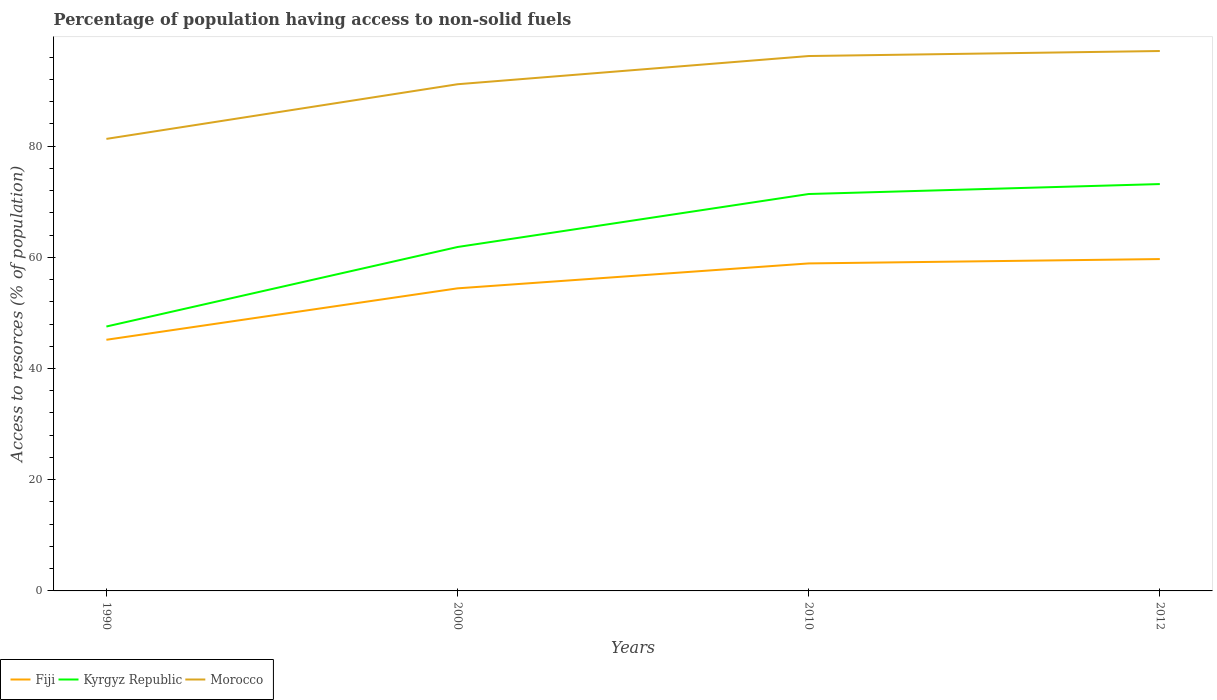How many different coloured lines are there?
Offer a terse response. 3. Is the number of lines equal to the number of legend labels?
Give a very brief answer. Yes. Across all years, what is the maximum percentage of population having access to non-solid fuels in Fiji?
Offer a very short reply. 45.17. What is the total percentage of population having access to non-solid fuels in Kyrgyz Republic in the graph?
Your answer should be compact. -14.3. What is the difference between the highest and the second highest percentage of population having access to non-solid fuels in Morocco?
Provide a succinct answer. 15.8. What is the difference between the highest and the lowest percentage of population having access to non-solid fuels in Morocco?
Ensure brevity in your answer.  2. How many lines are there?
Keep it short and to the point. 3. Where does the legend appear in the graph?
Provide a short and direct response. Bottom left. How are the legend labels stacked?
Offer a terse response. Horizontal. What is the title of the graph?
Provide a succinct answer. Percentage of population having access to non-solid fuels. What is the label or title of the X-axis?
Ensure brevity in your answer.  Years. What is the label or title of the Y-axis?
Provide a short and direct response. Access to resorces (% of population). What is the Access to resorces (% of population) of Fiji in 1990?
Make the answer very short. 45.17. What is the Access to resorces (% of population) of Kyrgyz Republic in 1990?
Your response must be concise. 47.55. What is the Access to resorces (% of population) in Morocco in 1990?
Give a very brief answer. 81.3. What is the Access to resorces (% of population) in Fiji in 2000?
Provide a succinct answer. 54.42. What is the Access to resorces (% of population) in Kyrgyz Republic in 2000?
Provide a succinct answer. 61.85. What is the Access to resorces (% of population) in Morocco in 2000?
Offer a terse response. 91.13. What is the Access to resorces (% of population) of Fiji in 2010?
Provide a short and direct response. 58.9. What is the Access to resorces (% of population) of Kyrgyz Republic in 2010?
Offer a very short reply. 71.38. What is the Access to resorces (% of population) in Morocco in 2010?
Your answer should be very brief. 96.2. What is the Access to resorces (% of population) of Fiji in 2012?
Make the answer very short. 59.68. What is the Access to resorces (% of population) in Kyrgyz Republic in 2012?
Provide a short and direct response. 73.18. What is the Access to resorces (% of population) of Morocco in 2012?
Make the answer very short. 97.1. Across all years, what is the maximum Access to resorces (% of population) in Fiji?
Make the answer very short. 59.68. Across all years, what is the maximum Access to resorces (% of population) in Kyrgyz Republic?
Provide a short and direct response. 73.18. Across all years, what is the maximum Access to resorces (% of population) of Morocco?
Ensure brevity in your answer.  97.1. Across all years, what is the minimum Access to resorces (% of population) in Fiji?
Ensure brevity in your answer.  45.17. Across all years, what is the minimum Access to resorces (% of population) in Kyrgyz Republic?
Provide a short and direct response. 47.55. Across all years, what is the minimum Access to resorces (% of population) of Morocco?
Offer a very short reply. 81.3. What is the total Access to resorces (% of population) of Fiji in the graph?
Offer a terse response. 218.17. What is the total Access to resorces (% of population) in Kyrgyz Republic in the graph?
Keep it short and to the point. 253.97. What is the total Access to resorces (% of population) of Morocco in the graph?
Your answer should be very brief. 365.73. What is the difference between the Access to resorces (% of population) of Fiji in 1990 and that in 2000?
Give a very brief answer. -9.25. What is the difference between the Access to resorces (% of population) in Kyrgyz Republic in 1990 and that in 2000?
Keep it short and to the point. -14.3. What is the difference between the Access to resorces (% of population) in Morocco in 1990 and that in 2000?
Make the answer very short. -9.83. What is the difference between the Access to resorces (% of population) in Fiji in 1990 and that in 2010?
Keep it short and to the point. -13.73. What is the difference between the Access to resorces (% of population) of Kyrgyz Republic in 1990 and that in 2010?
Your answer should be compact. -23.83. What is the difference between the Access to resorces (% of population) of Morocco in 1990 and that in 2010?
Provide a short and direct response. -14.9. What is the difference between the Access to resorces (% of population) in Fiji in 1990 and that in 2012?
Offer a very short reply. -14.52. What is the difference between the Access to resorces (% of population) in Kyrgyz Republic in 1990 and that in 2012?
Provide a succinct answer. -25.62. What is the difference between the Access to resorces (% of population) of Morocco in 1990 and that in 2012?
Make the answer very short. -15.8. What is the difference between the Access to resorces (% of population) in Fiji in 2000 and that in 2010?
Give a very brief answer. -4.48. What is the difference between the Access to resorces (% of population) in Kyrgyz Republic in 2000 and that in 2010?
Your response must be concise. -9.53. What is the difference between the Access to resorces (% of population) in Morocco in 2000 and that in 2010?
Keep it short and to the point. -5.07. What is the difference between the Access to resorces (% of population) of Fiji in 2000 and that in 2012?
Make the answer very short. -5.26. What is the difference between the Access to resorces (% of population) in Kyrgyz Republic in 2000 and that in 2012?
Give a very brief answer. -11.32. What is the difference between the Access to resorces (% of population) of Morocco in 2000 and that in 2012?
Offer a terse response. -5.98. What is the difference between the Access to resorces (% of population) of Fiji in 2010 and that in 2012?
Offer a very short reply. -0.78. What is the difference between the Access to resorces (% of population) of Kyrgyz Republic in 2010 and that in 2012?
Provide a succinct answer. -1.79. What is the difference between the Access to resorces (% of population) of Morocco in 2010 and that in 2012?
Your answer should be very brief. -0.9. What is the difference between the Access to resorces (% of population) of Fiji in 1990 and the Access to resorces (% of population) of Kyrgyz Republic in 2000?
Provide a succinct answer. -16.69. What is the difference between the Access to resorces (% of population) of Fiji in 1990 and the Access to resorces (% of population) of Morocco in 2000?
Your response must be concise. -45.96. What is the difference between the Access to resorces (% of population) of Kyrgyz Republic in 1990 and the Access to resorces (% of population) of Morocco in 2000?
Offer a terse response. -43.57. What is the difference between the Access to resorces (% of population) of Fiji in 1990 and the Access to resorces (% of population) of Kyrgyz Republic in 2010?
Keep it short and to the point. -26.21. What is the difference between the Access to resorces (% of population) of Fiji in 1990 and the Access to resorces (% of population) of Morocco in 2010?
Provide a short and direct response. -51.03. What is the difference between the Access to resorces (% of population) of Kyrgyz Republic in 1990 and the Access to resorces (% of population) of Morocco in 2010?
Provide a succinct answer. -48.65. What is the difference between the Access to resorces (% of population) of Fiji in 1990 and the Access to resorces (% of population) of Kyrgyz Republic in 2012?
Make the answer very short. -28.01. What is the difference between the Access to resorces (% of population) of Fiji in 1990 and the Access to resorces (% of population) of Morocco in 2012?
Keep it short and to the point. -51.93. What is the difference between the Access to resorces (% of population) of Kyrgyz Republic in 1990 and the Access to resorces (% of population) of Morocco in 2012?
Make the answer very short. -49.55. What is the difference between the Access to resorces (% of population) in Fiji in 2000 and the Access to resorces (% of population) in Kyrgyz Republic in 2010?
Make the answer very short. -16.96. What is the difference between the Access to resorces (% of population) in Fiji in 2000 and the Access to resorces (% of population) in Morocco in 2010?
Your response must be concise. -41.78. What is the difference between the Access to resorces (% of population) in Kyrgyz Republic in 2000 and the Access to resorces (% of population) in Morocco in 2010?
Make the answer very short. -34.35. What is the difference between the Access to resorces (% of population) of Fiji in 2000 and the Access to resorces (% of population) of Kyrgyz Republic in 2012?
Offer a terse response. -18.76. What is the difference between the Access to resorces (% of population) of Fiji in 2000 and the Access to resorces (% of population) of Morocco in 2012?
Keep it short and to the point. -42.68. What is the difference between the Access to resorces (% of population) of Kyrgyz Republic in 2000 and the Access to resorces (% of population) of Morocco in 2012?
Your response must be concise. -35.25. What is the difference between the Access to resorces (% of population) of Fiji in 2010 and the Access to resorces (% of population) of Kyrgyz Republic in 2012?
Keep it short and to the point. -14.27. What is the difference between the Access to resorces (% of population) of Fiji in 2010 and the Access to resorces (% of population) of Morocco in 2012?
Provide a succinct answer. -38.2. What is the difference between the Access to resorces (% of population) in Kyrgyz Republic in 2010 and the Access to resorces (% of population) in Morocco in 2012?
Offer a terse response. -25.72. What is the average Access to resorces (% of population) in Fiji per year?
Provide a short and direct response. 54.54. What is the average Access to resorces (% of population) of Kyrgyz Republic per year?
Keep it short and to the point. 63.49. What is the average Access to resorces (% of population) in Morocco per year?
Your response must be concise. 91.43. In the year 1990, what is the difference between the Access to resorces (% of population) of Fiji and Access to resorces (% of population) of Kyrgyz Republic?
Provide a succinct answer. -2.38. In the year 1990, what is the difference between the Access to resorces (% of population) in Fiji and Access to resorces (% of population) in Morocco?
Ensure brevity in your answer.  -36.13. In the year 1990, what is the difference between the Access to resorces (% of population) in Kyrgyz Republic and Access to resorces (% of population) in Morocco?
Provide a short and direct response. -33.75. In the year 2000, what is the difference between the Access to resorces (% of population) of Fiji and Access to resorces (% of population) of Kyrgyz Republic?
Offer a terse response. -7.43. In the year 2000, what is the difference between the Access to resorces (% of population) in Fiji and Access to resorces (% of population) in Morocco?
Offer a very short reply. -36.71. In the year 2000, what is the difference between the Access to resorces (% of population) of Kyrgyz Republic and Access to resorces (% of population) of Morocco?
Offer a terse response. -29.27. In the year 2010, what is the difference between the Access to resorces (% of population) in Fiji and Access to resorces (% of population) in Kyrgyz Republic?
Make the answer very short. -12.48. In the year 2010, what is the difference between the Access to resorces (% of population) in Fiji and Access to resorces (% of population) in Morocco?
Provide a succinct answer. -37.3. In the year 2010, what is the difference between the Access to resorces (% of population) of Kyrgyz Republic and Access to resorces (% of population) of Morocco?
Your response must be concise. -24.82. In the year 2012, what is the difference between the Access to resorces (% of population) in Fiji and Access to resorces (% of population) in Kyrgyz Republic?
Your answer should be very brief. -13.49. In the year 2012, what is the difference between the Access to resorces (% of population) in Fiji and Access to resorces (% of population) in Morocco?
Keep it short and to the point. -37.42. In the year 2012, what is the difference between the Access to resorces (% of population) in Kyrgyz Republic and Access to resorces (% of population) in Morocco?
Make the answer very short. -23.93. What is the ratio of the Access to resorces (% of population) of Fiji in 1990 to that in 2000?
Your response must be concise. 0.83. What is the ratio of the Access to resorces (% of population) of Kyrgyz Republic in 1990 to that in 2000?
Offer a very short reply. 0.77. What is the ratio of the Access to resorces (% of population) of Morocco in 1990 to that in 2000?
Ensure brevity in your answer.  0.89. What is the ratio of the Access to resorces (% of population) in Fiji in 1990 to that in 2010?
Your answer should be compact. 0.77. What is the ratio of the Access to resorces (% of population) of Kyrgyz Republic in 1990 to that in 2010?
Your answer should be compact. 0.67. What is the ratio of the Access to resorces (% of population) of Morocco in 1990 to that in 2010?
Your answer should be compact. 0.85. What is the ratio of the Access to resorces (% of population) in Fiji in 1990 to that in 2012?
Your answer should be very brief. 0.76. What is the ratio of the Access to resorces (% of population) in Kyrgyz Republic in 1990 to that in 2012?
Your answer should be compact. 0.65. What is the ratio of the Access to resorces (% of population) of Morocco in 1990 to that in 2012?
Your response must be concise. 0.84. What is the ratio of the Access to resorces (% of population) of Fiji in 2000 to that in 2010?
Give a very brief answer. 0.92. What is the ratio of the Access to resorces (% of population) of Kyrgyz Republic in 2000 to that in 2010?
Make the answer very short. 0.87. What is the ratio of the Access to resorces (% of population) of Morocco in 2000 to that in 2010?
Provide a succinct answer. 0.95. What is the ratio of the Access to resorces (% of population) of Fiji in 2000 to that in 2012?
Provide a succinct answer. 0.91. What is the ratio of the Access to resorces (% of population) of Kyrgyz Republic in 2000 to that in 2012?
Your response must be concise. 0.85. What is the ratio of the Access to resorces (% of population) of Morocco in 2000 to that in 2012?
Offer a very short reply. 0.94. What is the ratio of the Access to resorces (% of population) in Fiji in 2010 to that in 2012?
Keep it short and to the point. 0.99. What is the ratio of the Access to resorces (% of population) of Kyrgyz Republic in 2010 to that in 2012?
Your response must be concise. 0.98. What is the ratio of the Access to resorces (% of population) of Morocco in 2010 to that in 2012?
Give a very brief answer. 0.99. What is the difference between the highest and the second highest Access to resorces (% of population) of Fiji?
Ensure brevity in your answer.  0.78. What is the difference between the highest and the second highest Access to resorces (% of population) of Kyrgyz Republic?
Your answer should be very brief. 1.79. What is the difference between the highest and the second highest Access to resorces (% of population) in Morocco?
Keep it short and to the point. 0.9. What is the difference between the highest and the lowest Access to resorces (% of population) of Fiji?
Your response must be concise. 14.52. What is the difference between the highest and the lowest Access to resorces (% of population) of Kyrgyz Republic?
Offer a terse response. 25.62. What is the difference between the highest and the lowest Access to resorces (% of population) of Morocco?
Your answer should be very brief. 15.8. 